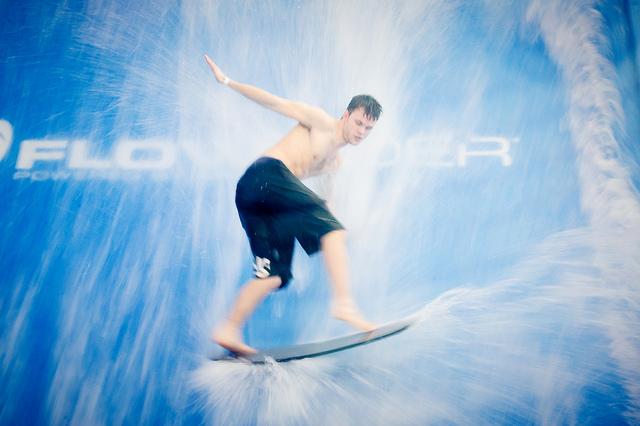Was this Photoshop used to make this?
Give a very brief answer. Yes. Is the man surfing?
Be succinct. Yes. What color are the boys shorts?
Write a very short answer. Blue. 